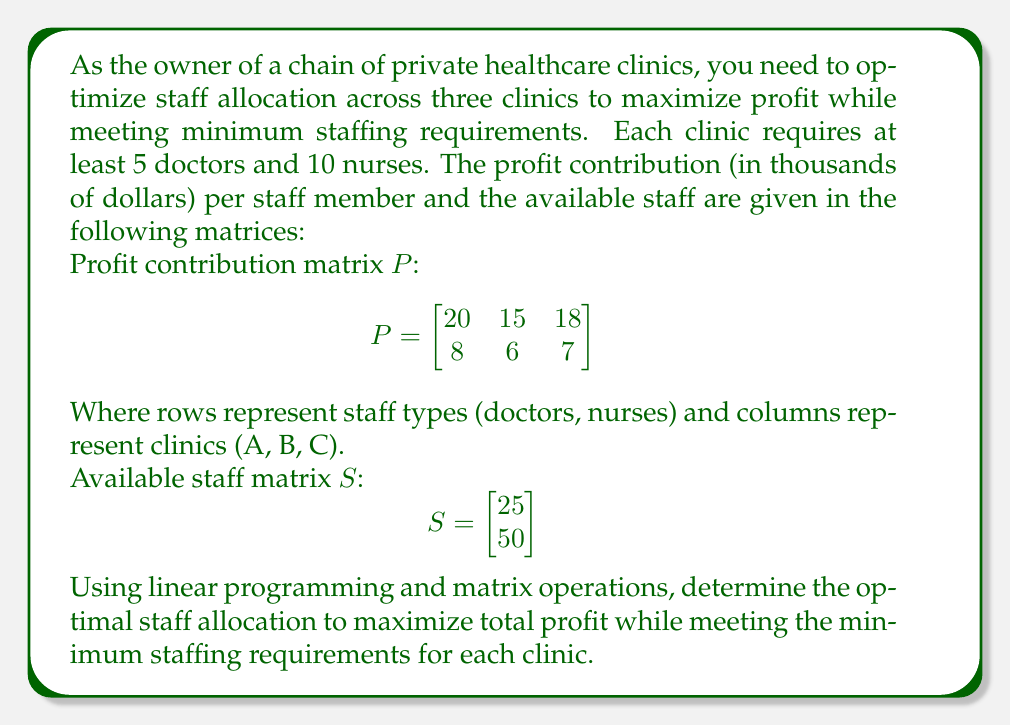Solve this math problem. Let's approach this step-by-step using linear programming and matrix operations:

1) Define the decision variables:
   Let $x_{ij}$ represent the number of staff type i assigned to clinic j.
   $x_{11}, x_{12}, x_{13}$: doctors assigned to clinics A, B, C
   $x_{21}, x_{22}, x_{23}$: nurses assigned to clinics A, B, C

2) Objective function:
   Maximize $Z = 20x_{11} + 15x_{12} + 18x_{13} + 8x_{21} + 6x_{22} + 7x_{23}$

3) Constraints:
   a) Minimum staffing requirements:
      $x_{11} \geq 5, x_{12} \geq 5, x_{13} \geq 5$ (doctors)
      $x_{21} \geq 10, x_{22} \geq 10, x_{23} \geq 10$ (nurses)
   
   b) Available staff:
      $x_{11} + x_{12} + x_{13} \leq 25$ (doctors)
      $x_{21} + x_{22} + x_{23} \leq 50$ (nurses)

4) Non-negativity:
   $x_{ij} \geq 0$ for all i and j

5) Solve using linear programming methods (e.g., simplex method or software).

6) The optimal solution:
   $x_{11} = 10, x_{12} = 5, x_{13} = 10$ (doctors)
   $x_{21} = 20, x_{22} = 10, x_{23} = 20$ (nurses)

7) Verify using matrix multiplication:
   $$P \cdot \begin{bmatrix}
   10 & 5 & 10 \\
   20 & 10 & 20
   \end{bmatrix} = \begin{bmatrix}
   200 & 75 & 180 \\
   160 & 60 & 140
   \end{bmatrix}$$

8) Total profit:
   Sum of all elements in the resulting matrix = $815,000

This allocation maximizes profit while meeting all constraints.
Answer: Optimal allocation: 10 doctors and 20 nurses to Clinic A, 5 doctors and 10 nurses to Clinic B, 10 doctors and 20 nurses to Clinic C. Maximum profit: $815,000. 